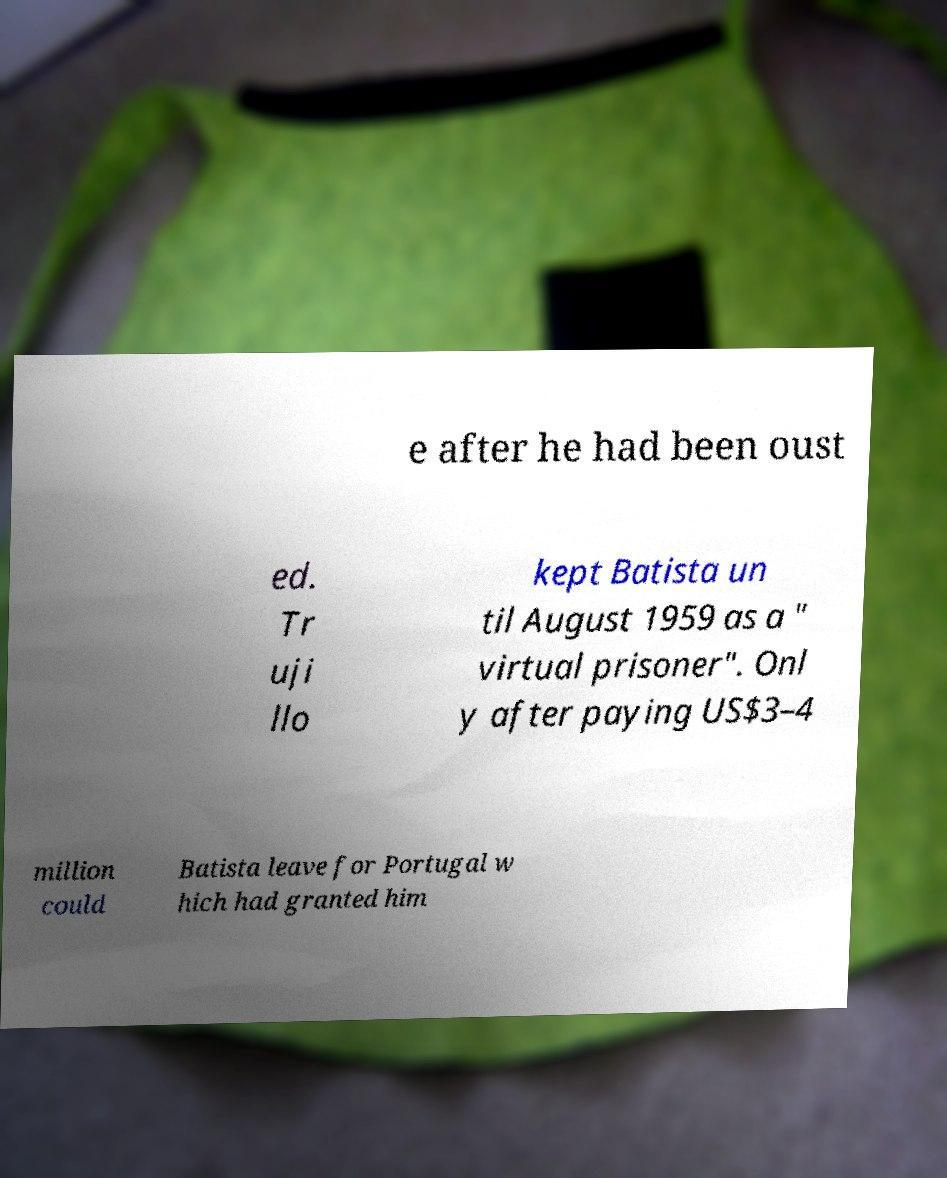Please read and relay the text visible in this image. What does it say? e after he had been oust ed. Tr uji llo kept Batista un til August 1959 as a " virtual prisoner". Onl y after paying US$3–4 million could Batista leave for Portugal w hich had granted him 